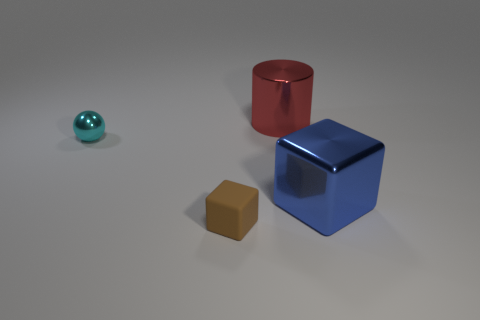Add 1 large red shiny cylinders. How many objects exist? 5 Add 4 large blue blocks. How many large blue blocks exist? 5 Subtract 0 brown cylinders. How many objects are left? 4 Subtract all large red metal things. Subtract all big things. How many objects are left? 1 Add 4 small things. How many small things are left? 6 